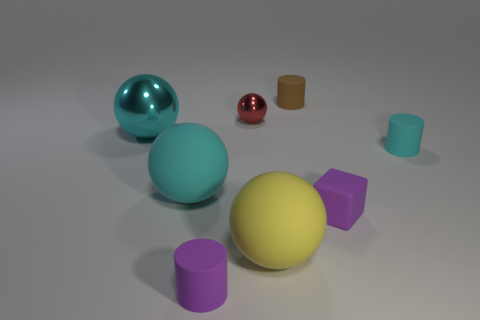Add 1 small green balls. How many objects exist? 9 Subtract all large yellow balls. How many balls are left? 3 Subtract all blocks. How many objects are left? 7 Subtract all red balls. How many balls are left? 3 Subtract 0 green spheres. How many objects are left? 8 Subtract 2 spheres. How many spheres are left? 2 Subtract all blue spheres. Subtract all blue cubes. How many spheres are left? 4 Subtract all cyan cylinders. How many cyan spheres are left? 2 Subtract all purple objects. Subtract all purple blocks. How many objects are left? 5 Add 4 yellow matte balls. How many yellow matte balls are left? 5 